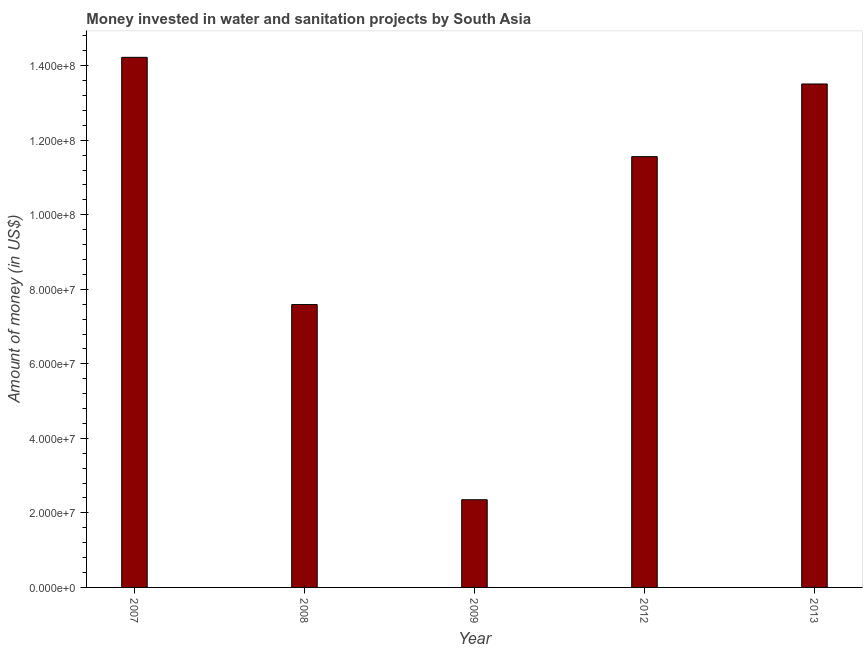Does the graph contain any zero values?
Keep it short and to the point. No. What is the title of the graph?
Offer a very short reply. Money invested in water and sanitation projects by South Asia. What is the label or title of the Y-axis?
Make the answer very short. Amount of money (in US$). What is the investment in 2007?
Provide a short and direct response. 1.42e+08. Across all years, what is the maximum investment?
Offer a terse response. 1.42e+08. Across all years, what is the minimum investment?
Provide a short and direct response. 2.35e+07. In which year was the investment maximum?
Provide a succinct answer. 2007. In which year was the investment minimum?
Make the answer very short. 2009. What is the sum of the investment?
Ensure brevity in your answer.  4.92e+08. What is the difference between the investment in 2012 and 2013?
Offer a terse response. -1.95e+07. What is the average investment per year?
Ensure brevity in your answer.  9.85e+07. What is the median investment?
Provide a succinct answer. 1.16e+08. In how many years, is the investment greater than 140000000 US$?
Your response must be concise. 1. What is the ratio of the investment in 2007 to that in 2008?
Keep it short and to the point. 1.87. Is the investment in 2008 less than that in 2009?
Your answer should be very brief. No. Is the difference between the investment in 2012 and 2013 greater than the difference between any two years?
Give a very brief answer. No. What is the difference between the highest and the second highest investment?
Make the answer very short. 7.15e+06. What is the difference between the highest and the lowest investment?
Give a very brief answer. 1.19e+08. What is the Amount of money (in US$) in 2007?
Keep it short and to the point. 1.42e+08. What is the Amount of money (in US$) of 2008?
Provide a succinct answer. 7.59e+07. What is the Amount of money (in US$) of 2009?
Your answer should be compact. 2.35e+07. What is the Amount of money (in US$) in 2012?
Offer a terse response. 1.16e+08. What is the Amount of money (in US$) in 2013?
Give a very brief answer. 1.35e+08. What is the difference between the Amount of money (in US$) in 2007 and 2008?
Give a very brief answer. 6.64e+07. What is the difference between the Amount of money (in US$) in 2007 and 2009?
Offer a very short reply. 1.19e+08. What is the difference between the Amount of money (in US$) in 2007 and 2012?
Your answer should be compact. 2.66e+07. What is the difference between the Amount of money (in US$) in 2007 and 2013?
Give a very brief answer. 7.15e+06. What is the difference between the Amount of money (in US$) in 2008 and 2009?
Keep it short and to the point. 5.24e+07. What is the difference between the Amount of money (in US$) in 2008 and 2012?
Keep it short and to the point. -3.97e+07. What is the difference between the Amount of money (in US$) in 2008 and 2013?
Provide a short and direct response. -5.92e+07. What is the difference between the Amount of money (in US$) in 2009 and 2012?
Give a very brief answer. -9.21e+07. What is the difference between the Amount of money (in US$) in 2009 and 2013?
Your answer should be very brief. -1.12e+08. What is the difference between the Amount of money (in US$) in 2012 and 2013?
Your response must be concise. -1.95e+07. What is the ratio of the Amount of money (in US$) in 2007 to that in 2008?
Offer a very short reply. 1.87. What is the ratio of the Amount of money (in US$) in 2007 to that in 2009?
Your answer should be compact. 6.04. What is the ratio of the Amount of money (in US$) in 2007 to that in 2012?
Give a very brief answer. 1.23. What is the ratio of the Amount of money (in US$) in 2007 to that in 2013?
Your answer should be compact. 1.05. What is the ratio of the Amount of money (in US$) in 2008 to that in 2009?
Offer a very short reply. 3.23. What is the ratio of the Amount of money (in US$) in 2008 to that in 2012?
Provide a short and direct response. 0.66. What is the ratio of the Amount of money (in US$) in 2008 to that in 2013?
Offer a terse response. 0.56. What is the ratio of the Amount of money (in US$) in 2009 to that in 2012?
Ensure brevity in your answer.  0.2. What is the ratio of the Amount of money (in US$) in 2009 to that in 2013?
Keep it short and to the point. 0.17. What is the ratio of the Amount of money (in US$) in 2012 to that in 2013?
Ensure brevity in your answer.  0.86. 